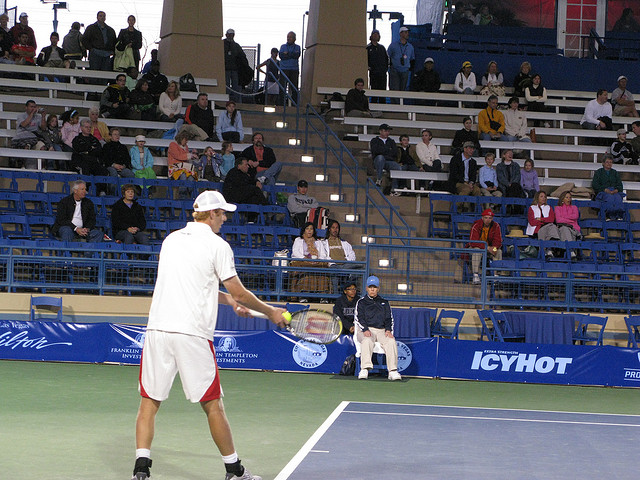<image>Are those his family watching him? I don't know if those are his family watching him. Are those his family watching him? I don't know if those are his family watching him. It can be no or unknown. 